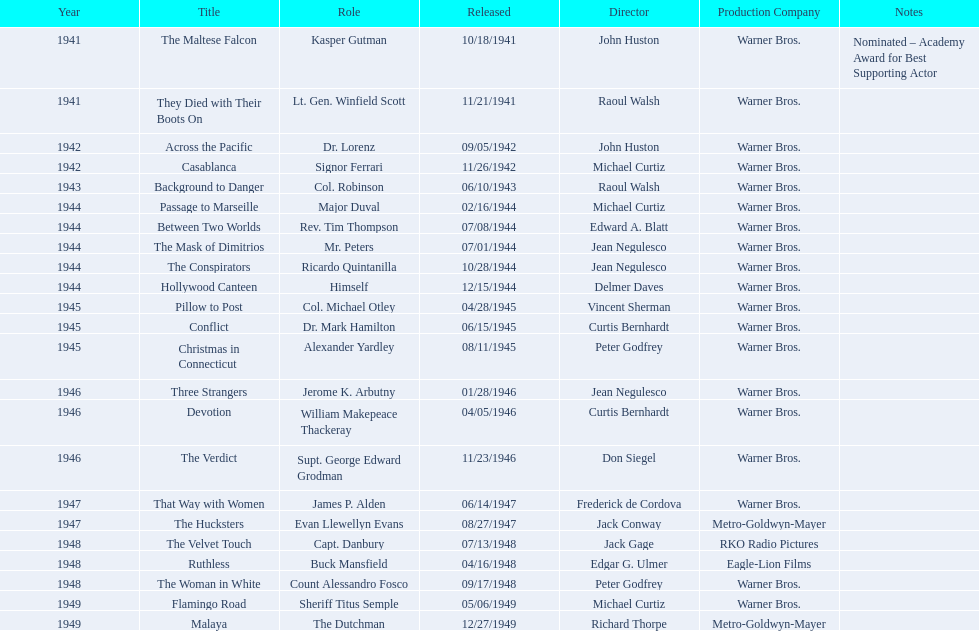What year was the movie that was nominated ? 1941. What was the title of the movie? The Maltese Falcon. 